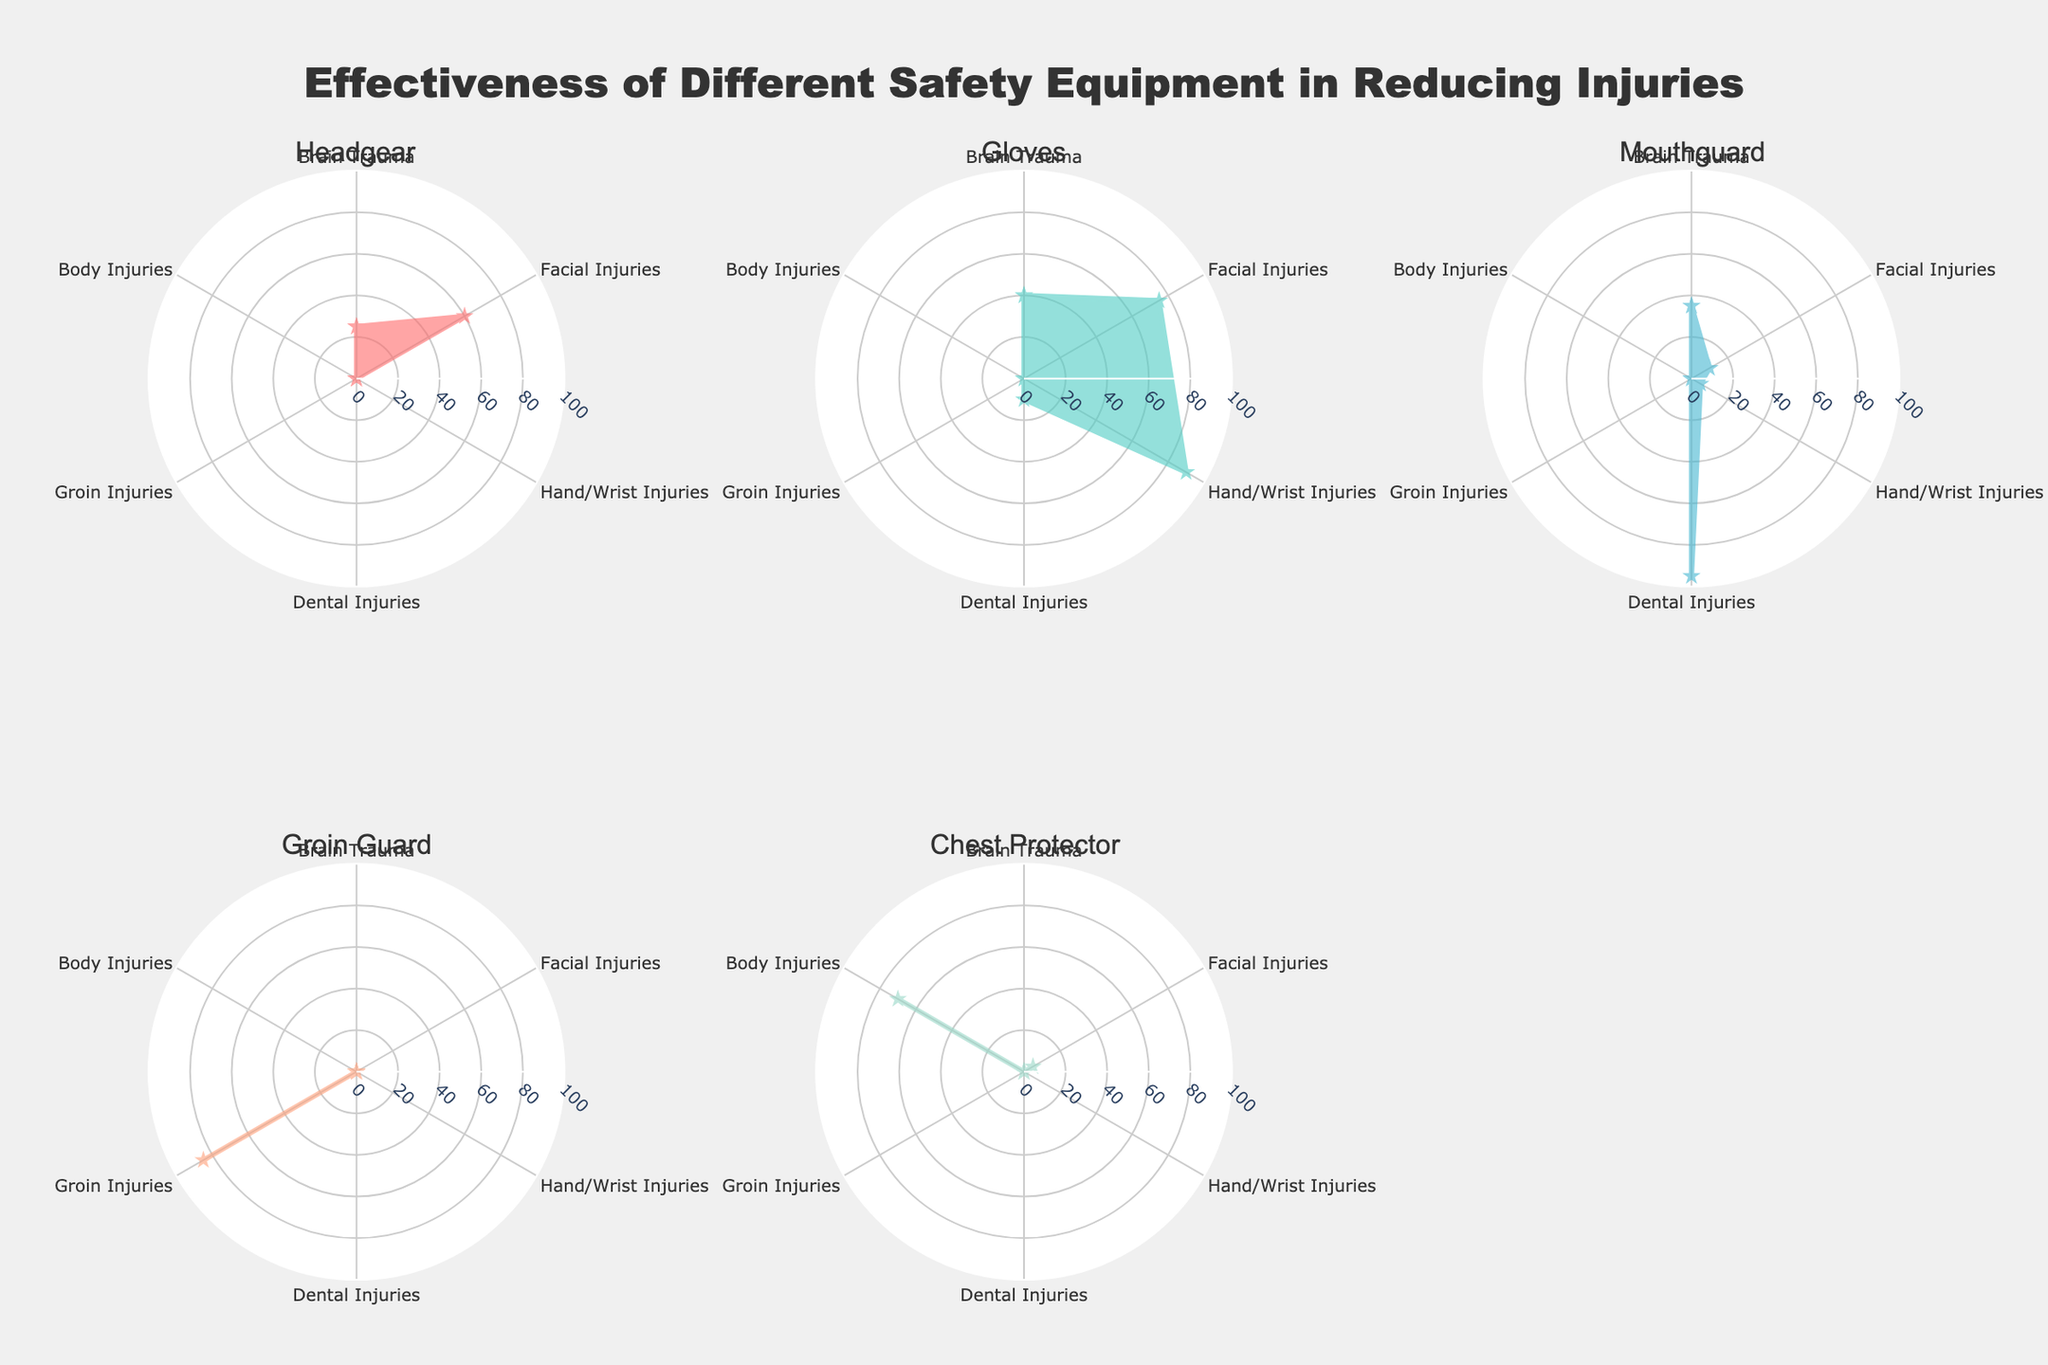What's the title of the figure? The figure's title is usually located at the top of the plot and provides an overview of the subject. In this case, the title is clearly stated there.
Answer: Effectiveness of Different Safety Equipment in Reducing Injuries Which equipment is most effective in reducing dental injuries? To determine this, look at the subplot for each type of equipment and find the one with the highest value for dental injuries. The subplot for Mouthguard shows the highest percentage.
Answer: Mouthguard How many equipment types are plotted in the figure? Count the number of subplots or separate radar charts present in the figure to find the number of equipment types. There are six subplots, each representing one type of equipment.
Answer: Six Which equipment provides the least protection against brain trauma? Examine the Brain Trauma values in each radar chart and find the lowest percentage. Both Groin Guard and Chest Protector have a value of 0 for Brain Trauma.
Answer: Groin Guard and Chest Protector What's the range of effectiveness percentages shown in the figure? Look at the radial axis of the radar charts to determine the range. It is shown that the percentages go from 0 to 100.
Answer: 0 to 100 Which equipment is most effective in reducing hand/wrist injuries? Look at the Hand/Wrist Injuries values in each radar chart. Gloves have the highest percentage at 90.
Answer: Gloves Is there any equipment that shows zero effectiveness in multiple injury types? Scan each equipment's radar chart for zeros across multiple injury types. Chest Protector and Groin Guard both show zero for multiple injury types.
Answer: Yes, Chest Protector and Groin Guard What injury type does Gloves provide the least protection for? Check the injury types for Gloves and find the lowest percentage. Dental Injuries have the lowest value at 10.
Answer: Dental Injuries Which equipment shows some effectiveness (non-zero) for body injuries? Look at the Body Injuries axis in each radar chart and identify any non-zero values. Only Chest Protector shows effectiveness with a value of 70.
Answer: Chest Protector Comparing Headgear and Mouthguard, which one is more effective in reducing facial injuries? Compare the Facial Injuries percentages in the subplots for Headgear and Mouthguard. Mouthguard has a value of 10, whereas Headgear has a significantly higher value of 60.
Answer: Headgear 